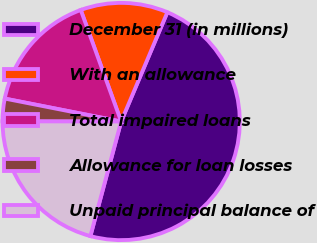<chart> <loc_0><loc_0><loc_500><loc_500><pie_chart><fcel>December 31 (in millions)<fcel>With an allowance<fcel>Total impaired loans<fcel>Allowance for loan losses<fcel>Unpaid principal balance of<nl><fcel>47.81%<fcel>11.9%<fcel>16.37%<fcel>3.07%<fcel>20.85%<nl></chart> 